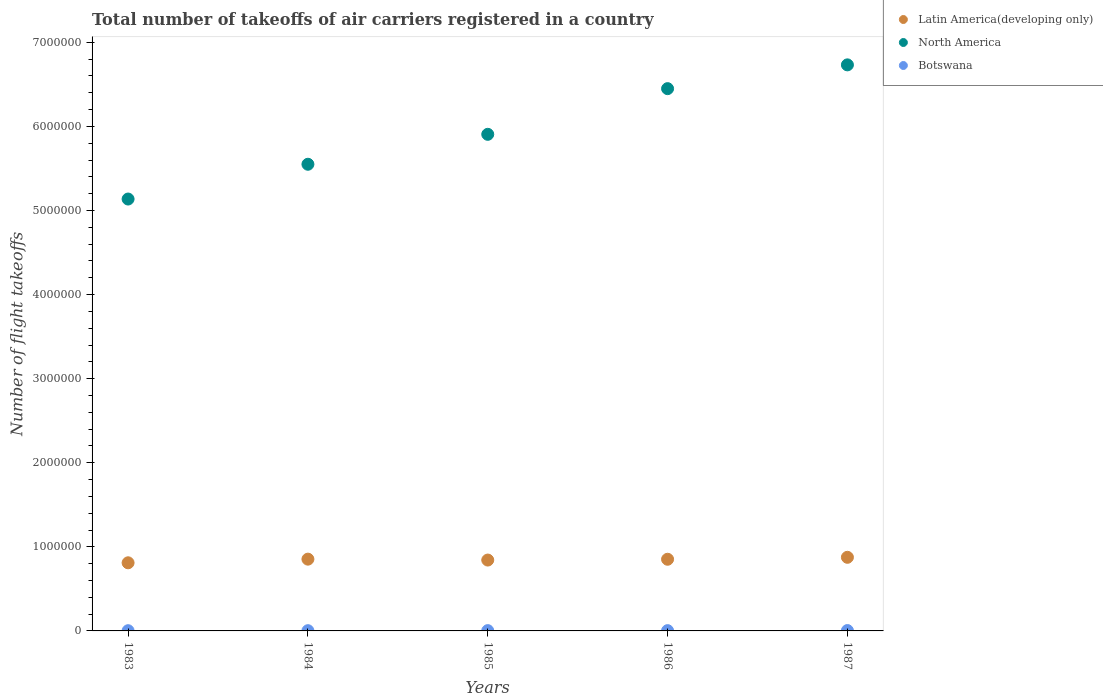Is the number of dotlines equal to the number of legend labels?
Your answer should be very brief. Yes. What is the total number of flight takeoffs in Latin America(developing only) in 1983?
Provide a short and direct response. 8.10e+05. Across all years, what is the maximum total number of flight takeoffs in Latin America(developing only)?
Provide a short and direct response. 8.76e+05. Across all years, what is the minimum total number of flight takeoffs in Botswana?
Keep it short and to the point. 2600. In which year was the total number of flight takeoffs in North America maximum?
Provide a succinct answer. 1987. In which year was the total number of flight takeoffs in Latin America(developing only) minimum?
Provide a succinct answer. 1983. What is the total total number of flight takeoffs in Latin America(developing only) in the graph?
Your answer should be compact. 4.23e+06. What is the difference between the total number of flight takeoffs in Botswana in 1985 and that in 1987?
Offer a very short reply. -800. What is the difference between the total number of flight takeoffs in Botswana in 1986 and the total number of flight takeoffs in Latin America(developing only) in 1987?
Your answer should be very brief. -8.72e+05. What is the average total number of flight takeoffs in North America per year?
Keep it short and to the point. 5.95e+06. In the year 1987, what is the difference between the total number of flight takeoffs in North America and total number of flight takeoffs in Botswana?
Your answer should be very brief. 6.73e+06. What is the ratio of the total number of flight takeoffs in Botswana in 1984 to that in 1986?
Your answer should be very brief. 0.85. What is the difference between the highest and the second highest total number of flight takeoffs in Botswana?
Offer a terse response. 800. What is the difference between the highest and the lowest total number of flight takeoffs in Latin America(developing only)?
Your answer should be compact. 6.53e+04. Is the total number of flight takeoffs in North America strictly greater than the total number of flight takeoffs in Latin America(developing only) over the years?
Provide a short and direct response. Yes. How many dotlines are there?
Offer a very short reply. 3. Does the graph contain any zero values?
Ensure brevity in your answer.  No. Does the graph contain grids?
Give a very brief answer. No. Where does the legend appear in the graph?
Offer a very short reply. Top right. How many legend labels are there?
Make the answer very short. 3. How are the legend labels stacked?
Offer a terse response. Vertical. What is the title of the graph?
Give a very brief answer. Total number of takeoffs of air carriers registered in a country. Does "French Polynesia" appear as one of the legend labels in the graph?
Keep it short and to the point. No. What is the label or title of the X-axis?
Provide a short and direct response. Years. What is the label or title of the Y-axis?
Provide a short and direct response. Number of flight takeoffs. What is the Number of flight takeoffs in Latin America(developing only) in 1983?
Give a very brief answer. 8.10e+05. What is the Number of flight takeoffs in North America in 1983?
Offer a very short reply. 5.14e+06. What is the Number of flight takeoffs of Botswana in 1983?
Your answer should be compact. 2600. What is the Number of flight takeoffs in Latin America(developing only) in 1984?
Ensure brevity in your answer.  8.54e+05. What is the Number of flight takeoffs of North America in 1984?
Make the answer very short. 5.55e+06. What is the Number of flight takeoffs of Botswana in 1984?
Offer a terse response. 2800. What is the Number of flight takeoffs of Latin America(developing only) in 1985?
Offer a terse response. 8.43e+05. What is the Number of flight takeoffs of North America in 1985?
Your response must be concise. 5.91e+06. What is the Number of flight takeoffs in Botswana in 1985?
Keep it short and to the point. 3500. What is the Number of flight takeoffs of Latin America(developing only) in 1986?
Ensure brevity in your answer.  8.52e+05. What is the Number of flight takeoffs in North America in 1986?
Keep it short and to the point. 6.45e+06. What is the Number of flight takeoffs in Botswana in 1986?
Keep it short and to the point. 3300. What is the Number of flight takeoffs in Latin America(developing only) in 1987?
Your answer should be compact. 8.76e+05. What is the Number of flight takeoffs of North America in 1987?
Make the answer very short. 6.73e+06. What is the Number of flight takeoffs in Botswana in 1987?
Your answer should be very brief. 4300. Across all years, what is the maximum Number of flight takeoffs in Latin America(developing only)?
Ensure brevity in your answer.  8.76e+05. Across all years, what is the maximum Number of flight takeoffs of North America?
Offer a very short reply. 6.73e+06. Across all years, what is the maximum Number of flight takeoffs of Botswana?
Provide a succinct answer. 4300. Across all years, what is the minimum Number of flight takeoffs of Latin America(developing only)?
Your answer should be very brief. 8.10e+05. Across all years, what is the minimum Number of flight takeoffs in North America?
Your answer should be compact. 5.14e+06. Across all years, what is the minimum Number of flight takeoffs of Botswana?
Your answer should be compact. 2600. What is the total Number of flight takeoffs of Latin America(developing only) in the graph?
Provide a succinct answer. 4.23e+06. What is the total Number of flight takeoffs of North America in the graph?
Give a very brief answer. 2.98e+07. What is the total Number of flight takeoffs in Botswana in the graph?
Provide a succinct answer. 1.65e+04. What is the difference between the Number of flight takeoffs in Latin America(developing only) in 1983 and that in 1984?
Ensure brevity in your answer.  -4.33e+04. What is the difference between the Number of flight takeoffs in North America in 1983 and that in 1984?
Your answer should be very brief. -4.14e+05. What is the difference between the Number of flight takeoffs in Botswana in 1983 and that in 1984?
Give a very brief answer. -200. What is the difference between the Number of flight takeoffs of Latin America(developing only) in 1983 and that in 1985?
Your answer should be very brief. -3.26e+04. What is the difference between the Number of flight takeoffs of North America in 1983 and that in 1985?
Your answer should be compact. -7.70e+05. What is the difference between the Number of flight takeoffs of Botswana in 1983 and that in 1985?
Ensure brevity in your answer.  -900. What is the difference between the Number of flight takeoffs of Latin America(developing only) in 1983 and that in 1986?
Your answer should be very brief. -4.21e+04. What is the difference between the Number of flight takeoffs in North America in 1983 and that in 1986?
Give a very brief answer. -1.31e+06. What is the difference between the Number of flight takeoffs of Botswana in 1983 and that in 1986?
Provide a short and direct response. -700. What is the difference between the Number of flight takeoffs of Latin America(developing only) in 1983 and that in 1987?
Ensure brevity in your answer.  -6.53e+04. What is the difference between the Number of flight takeoffs of North America in 1983 and that in 1987?
Provide a succinct answer. -1.60e+06. What is the difference between the Number of flight takeoffs in Botswana in 1983 and that in 1987?
Ensure brevity in your answer.  -1700. What is the difference between the Number of flight takeoffs in Latin America(developing only) in 1984 and that in 1985?
Provide a short and direct response. 1.07e+04. What is the difference between the Number of flight takeoffs of North America in 1984 and that in 1985?
Give a very brief answer. -3.56e+05. What is the difference between the Number of flight takeoffs in Botswana in 1984 and that in 1985?
Provide a short and direct response. -700. What is the difference between the Number of flight takeoffs of Latin America(developing only) in 1984 and that in 1986?
Provide a succinct answer. 1200. What is the difference between the Number of flight takeoffs in North America in 1984 and that in 1986?
Your answer should be compact. -8.99e+05. What is the difference between the Number of flight takeoffs of Botswana in 1984 and that in 1986?
Offer a very short reply. -500. What is the difference between the Number of flight takeoffs of Latin America(developing only) in 1984 and that in 1987?
Provide a succinct answer. -2.20e+04. What is the difference between the Number of flight takeoffs of North America in 1984 and that in 1987?
Keep it short and to the point. -1.18e+06. What is the difference between the Number of flight takeoffs of Botswana in 1984 and that in 1987?
Your response must be concise. -1500. What is the difference between the Number of flight takeoffs in Latin America(developing only) in 1985 and that in 1986?
Give a very brief answer. -9500. What is the difference between the Number of flight takeoffs of North America in 1985 and that in 1986?
Your response must be concise. -5.43e+05. What is the difference between the Number of flight takeoffs in Latin America(developing only) in 1985 and that in 1987?
Ensure brevity in your answer.  -3.27e+04. What is the difference between the Number of flight takeoffs of North America in 1985 and that in 1987?
Keep it short and to the point. -8.26e+05. What is the difference between the Number of flight takeoffs in Botswana in 1985 and that in 1987?
Give a very brief answer. -800. What is the difference between the Number of flight takeoffs in Latin America(developing only) in 1986 and that in 1987?
Give a very brief answer. -2.32e+04. What is the difference between the Number of flight takeoffs in North America in 1986 and that in 1987?
Your answer should be compact. -2.83e+05. What is the difference between the Number of flight takeoffs in Botswana in 1986 and that in 1987?
Keep it short and to the point. -1000. What is the difference between the Number of flight takeoffs in Latin America(developing only) in 1983 and the Number of flight takeoffs in North America in 1984?
Provide a succinct answer. -4.74e+06. What is the difference between the Number of flight takeoffs of Latin America(developing only) in 1983 and the Number of flight takeoffs of Botswana in 1984?
Give a very brief answer. 8.07e+05. What is the difference between the Number of flight takeoffs in North America in 1983 and the Number of flight takeoffs in Botswana in 1984?
Your response must be concise. 5.13e+06. What is the difference between the Number of flight takeoffs of Latin America(developing only) in 1983 and the Number of flight takeoffs of North America in 1985?
Provide a short and direct response. -5.10e+06. What is the difference between the Number of flight takeoffs in Latin America(developing only) in 1983 and the Number of flight takeoffs in Botswana in 1985?
Offer a very short reply. 8.07e+05. What is the difference between the Number of flight takeoffs of North America in 1983 and the Number of flight takeoffs of Botswana in 1985?
Your answer should be very brief. 5.13e+06. What is the difference between the Number of flight takeoffs in Latin America(developing only) in 1983 and the Number of flight takeoffs in North America in 1986?
Offer a very short reply. -5.64e+06. What is the difference between the Number of flight takeoffs in Latin America(developing only) in 1983 and the Number of flight takeoffs in Botswana in 1986?
Make the answer very short. 8.07e+05. What is the difference between the Number of flight takeoffs in North America in 1983 and the Number of flight takeoffs in Botswana in 1986?
Your response must be concise. 5.13e+06. What is the difference between the Number of flight takeoffs in Latin America(developing only) in 1983 and the Number of flight takeoffs in North America in 1987?
Your answer should be very brief. -5.92e+06. What is the difference between the Number of flight takeoffs of Latin America(developing only) in 1983 and the Number of flight takeoffs of Botswana in 1987?
Your answer should be very brief. 8.06e+05. What is the difference between the Number of flight takeoffs of North America in 1983 and the Number of flight takeoffs of Botswana in 1987?
Your response must be concise. 5.13e+06. What is the difference between the Number of flight takeoffs in Latin America(developing only) in 1984 and the Number of flight takeoffs in North America in 1985?
Give a very brief answer. -5.05e+06. What is the difference between the Number of flight takeoffs in Latin America(developing only) in 1984 and the Number of flight takeoffs in Botswana in 1985?
Offer a very short reply. 8.50e+05. What is the difference between the Number of flight takeoffs in North America in 1984 and the Number of flight takeoffs in Botswana in 1985?
Keep it short and to the point. 5.55e+06. What is the difference between the Number of flight takeoffs of Latin America(developing only) in 1984 and the Number of flight takeoffs of North America in 1986?
Offer a very short reply. -5.60e+06. What is the difference between the Number of flight takeoffs of Latin America(developing only) in 1984 and the Number of flight takeoffs of Botswana in 1986?
Ensure brevity in your answer.  8.50e+05. What is the difference between the Number of flight takeoffs in North America in 1984 and the Number of flight takeoffs in Botswana in 1986?
Make the answer very short. 5.55e+06. What is the difference between the Number of flight takeoffs in Latin America(developing only) in 1984 and the Number of flight takeoffs in North America in 1987?
Your response must be concise. -5.88e+06. What is the difference between the Number of flight takeoffs in Latin America(developing only) in 1984 and the Number of flight takeoffs in Botswana in 1987?
Your answer should be very brief. 8.49e+05. What is the difference between the Number of flight takeoffs in North America in 1984 and the Number of flight takeoffs in Botswana in 1987?
Provide a short and direct response. 5.55e+06. What is the difference between the Number of flight takeoffs of Latin America(developing only) in 1985 and the Number of flight takeoffs of North America in 1986?
Ensure brevity in your answer.  -5.61e+06. What is the difference between the Number of flight takeoffs in Latin America(developing only) in 1985 and the Number of flight takeoffs in Botswana in 1986?
Your answer should be compact. 8.40e+05. What is the difference between the Number of flight takeoffs in North America in 1985 and the Number of flight takeoffs in Botswana in 1986?
Make the answer very short. 5.90e+06. What is the difference between the Number of flight takeoffs of Latin America(developing only) in 1985 and the Number of flight takeoffs of North America in 1987?
Provide a short and direct response. -5.89e+06. What is the difference between the Number of flight takeoffs in Latin America(developing only) in 1985 and the Number of flight takeoffs in Botswana in 1987?
Give a very brief answer. 8.38e+05. What is the difference between the Number of flight takeoffs of North America in 1985 and the Number of flight takeoffs of Botswana in 1987?
Your answer should be very brief. 5.90e+06. What is the difference between the Number of flight takeoffs in Latin America(developing only) in 1986 and the Number of flight takeoffs in North America in 1987?
Your response must be concise. -5.88e+06. What is the difference between the Number of flight takeoffs in Latin America(developing only) in 1986 and the Number of flight takeoffs in Botswana in 1987?
Offer a terse response. 8.48e+05. What is the difference between the Number of flight takeoffs in North America in 1986 and the Number of flight takeoffs in Botswana in 1987?
Keep it short and to the point. 6.44e+06. What is the average Number of flight takeoffs of Latin America(developing only) per year?
Your response must be concise. 8.47e+05. What is the average Number of flight takeoffs of North America per year?
Offer a very short reply. 5.95e+06. What is the average Number of flight takeoffs of Botswana per year?
Your answer should be compact. 3300. In the year 1983, what is the difference between the Number of flight takeoffs in Latin America(developing only) and Number of flight takeoffs in North America?
Give a very brief answer. -4.33e+06. In the year 1983, what is the difference between the Number of flight takeoffs in Latin America(developing only) and Number of flight takeoffs in Botswana?
Your response must be concise. 8.08e+05. In the year 1983, what is the difference between the Number of flight takeoffs in North America and Number of flight takeoffs in Botswana?
Keep it short and to the point. 5.13e+06. In the year 1984, what is the difference between the Number of flight takeoffs in Latin America(developing only) and Number of flight takeoffs in North America?
Your answer should be compact. -4.70e+06. In the year 1984, what is the difference between the Number of flight takeoffs of Latin America(developing only) and Number of flight takeoffs of Botswana?
Offer a terse response. 8.51e+05. In the year 1984, what is the difference between the Number of flight takeoffs of North America and Number of flight takeoffs of Botswana?
Your answer should be very brief. 5.55e+06. In the year 1985, what is the difference between the Number of flight takeoffs of Latin America(developing only) and Number of flight takeoffs of North America?
Provide a succinct answer. -5.06e+06. In the year 1985, what is the difference between the Number of flight takeoffs of Latin America(developing only) and Number of flight takeoffs of Botswana?
Give a very brief answer. 8.39e+05. In the year 1985, what is the difference between the Number of flight takeoffs in North America and Number of flight takeoffs in Botswana?
Offer a very short reply. 5.90e+06. In the year 1986, what is the difference between the Number of flight takeoffs in Latin America(developing only) and Number of flight takeoffs in North America?
Make the answer very short. -5.60e+06. In the year 1986, what is the difference between the Number of flight takeoffs of Latin America(developing only) and Number of flight takeoffs of Botswana?
Your response must be concise. 8.49e+05. In the year 1986, what is the difference between the Number of flight takeoffs of North America and Number of flight takeoffs of Botswana?
Your answer should be compact. 6.45e+06. In the year 1987, what is the difference between the Number of flight takeoffs in Latin America(developing only) and Number of flight takeoffs in North America?
Your response must be concise. -5.86e+06. In the year 1987, what is the difference between the Number of flight takeoffs of Latin America(developing only) and Number of flight takeoffs of Botswana?
Provide a succinct answer. 8.71e+05. In the year 1987, what is the difference between the Number of flight takeoffs of North America and Number of flight takeoffs of Botswana?
Your response must be concise. 6.73e+06. What is the ratio of the Number of flight takeoffs of Latin America(developing only) in 1983 to that in 1984?
Make the answer very short. 0.95. What is the ratio of the Number of flight takeoffs in North America in 1983 to that in 1984?
Provide a succinct answer. 0.93. What is the ratio of the Number of flight takeoffs of Botswana in 1983 to that in 1984?
Give a very brief answer. 0.93. What is the ratio of the Number of flight takeoffs in Latin America(developing only) in 1983 to that in 1985?
Make the answer very short. 0.96. What is the ratio of the Number of flight takeoffs of North America in 1983 to that in 1985?
Give a very brief answer. 0.87. What is the ratio of the Number of flight takeoffs in Botswana in 1983 to that in 1985?
Provide a short and direct response. 0.74. What is the ratio of the Number of flight takeoffs in Latin America(developing only) in 1983 to that in 1986?
Offer a terse response. 0.95. What is the ratio of the Number of flight takeoffs in North America in 1983 to that in 1986?
Keep it short and to the point. 0.8. What is the ratio of the Number of flight takeoffs in Botswana in 1983 to that in 1986?
Provide a succinct answer. 0.79. What is the ratio of the Number of flight takeoffs of Latin America(developing only) in 1983 to that in 1987?
Give a very brief answer. 0.93. What is the ratio of the Number of flight takeoffs of North America in 1983 to that in 1987?
Make the answer very short. 0.76. What is the ratio of the Number of flight takeoffs of Botswana in 1983 to that in 1987?
Your answer should be very brief. 0.6. What is the ratio of the Number of flight takeoffs in Latin America(developing only) in 1984 to that in 1985?
Offer a very short reply. 1.01. What is the ratio of the Number of flight takeoffs in North America in 1984 to that in 1985?
Your response must be concise. 0.94. What is the ratio of the Number of flight takeoffs of Latin America(developing only) in 1984 to that in 1986?
Keep it short and to the point. 1. What is the ratio of the Number of flight takeoffs of North America in 1984 to that in 1986?
Give a very brief answer. 0.86. What is the ratio of the Number of flight takeoffs of Botswana in 1984 to that in 1986?
Provide a succinct answer. 0.85. What is the ratio of the Number of flight takeoffs of Latin America(developing only) in 1984 to that in 1987?
Provide a succinct answer. 0.97. What is the ratio of the Number of flight takeoffs in North America in 1984 to that in 1987?
Your response must be concise. 0.82. What is the ratio of the Number of flight takeoffs in Botswana in 1984 to that in 1987?
Ensure brevity in your answer.  0.65. What is the ratio of the Number of flight takeoffs of Latin America(developing only) in 1985 to that in 1986?
Keep it short and to the point. 0.99. What is the ratio of the Number of flight takeoffs in North America in 1985 to that in 1986?
Your answer should be very brief. 0.92. What is the ratio of the Number of flight takeoffs in Botswana in 1985 to that in 1986?
Provide a short and direct response. 1.06. What is the ratio of the Number of flight takeoffs in Latin America(developing only) in 1985 to that in 1987?
Provide a short and direct response. 0.96. What is the ratio of the Number of flight takeoffs of North America in 1985 to that in 1987?
Give a very brief answer. 0.88. What is the ratio of the Number of flight takeoffs in Botswana in 1985 to that in 1987?
Your response must be concise. 0.81. What is the ratio of the Number of flight takeoffs of Latin America(developing only) in 1986 to that in 1987?
Keep it short and to the point. 0.97. What is the ratio of the Number of flight takeoffs in North America in 1986 to that in 1987?
Provide a succinct answer. 0.96. What is the ratio of the Number of flight takeoffs in Botswana in 1986 to that in 1987?
Your response must be concise. 0.77. What is the difference between the highest and the second highest Number of flight takeoffs in Latin America(developing only)?
Keep it short and to the point. 2.20e+04. What is the difference between the highest and the second highest Number of flight takeoffs of North America?
Provide a succinct answer. 2.83e+05. What is the difference between the highest and the second highest Number of flight takeoffs in Botswana?
Your answer should be very brief. 800. What is the difference between the highest and the lowest Number of flight takeoffs in Latin America(developing only)?
Offer a terse response. 6.53e+04. What is the difference between the highest and the lowest Number of flight takeoffs of North America?
Offer a terse response. 1.60e+06. What is the difference between the highest and the lowest Number of flight takeoffs of Botswana?
Your answer should be very brief. 1700. 